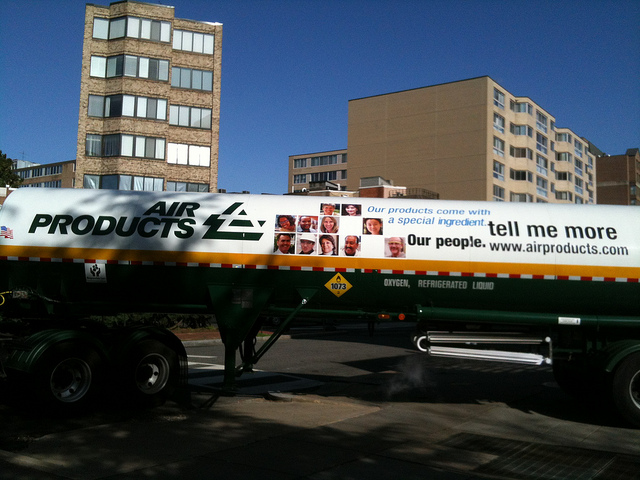Identify and read out the text in this image. AIR AIR PRODUCTS tell me more ingredient. special with come products Our www.airproducts.com people. Our REFRIGERATED OXYGEN 1013 